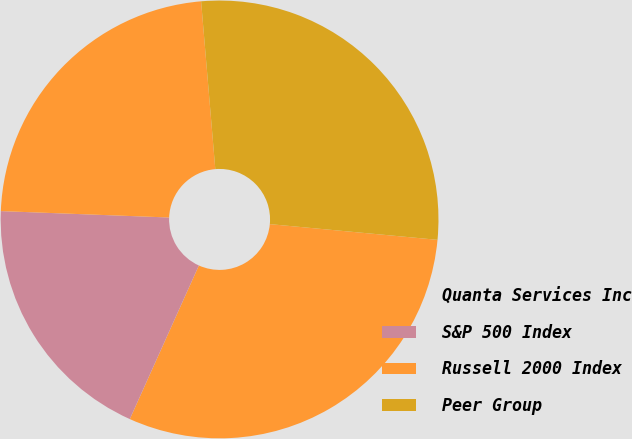Convert chart. <chart><loc_0><loc_0><loc_500><loc_500><pie_chart><fcel>Quanta Services Inc<fcel>S&P 500 Index<fcel>Russell 2000 Index<fcel>Peer Group<nl><fcel>30.24%<fcel>18.88%<fcel>23.05%<fcel>27.83%<nl></chart> 